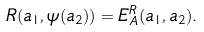<formula> <loc_0><loc_0><loc_500><loc_500>R ( a _ { 1 } , \psi ( a _ { 2 } ) ) = E _ { A } ^ { R } ( a _ { 1 } , a _ { 2 } ) .</formula> 